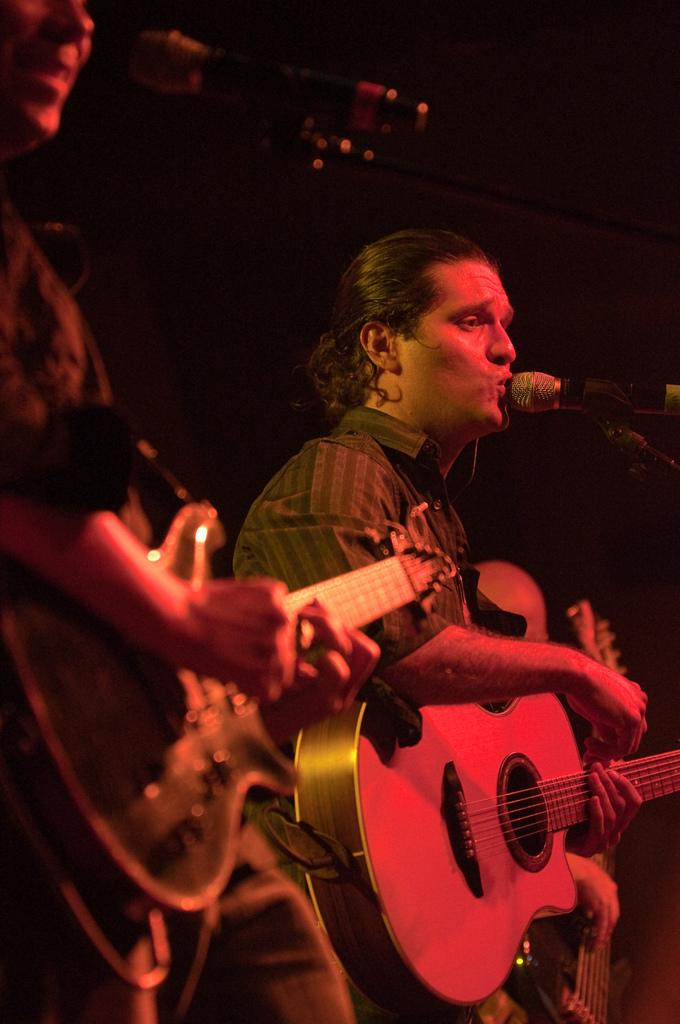What are the men in the image doing? The men in the image are standing and holding guitars. What object is present in the image that is typically used for amplifying sound? There is a microphone in the image. Which man is positioned in front of the microphone? One man is in front of the microphone. What is the man in front of the microphone doing? The man in front of the microphone is singing. Can you see a snail crawling on the guitar in the image? No, there is no snail present in the image. What type of drum is being played by the man in the image? There is no drum visible in the image; the men are holding guitars. 